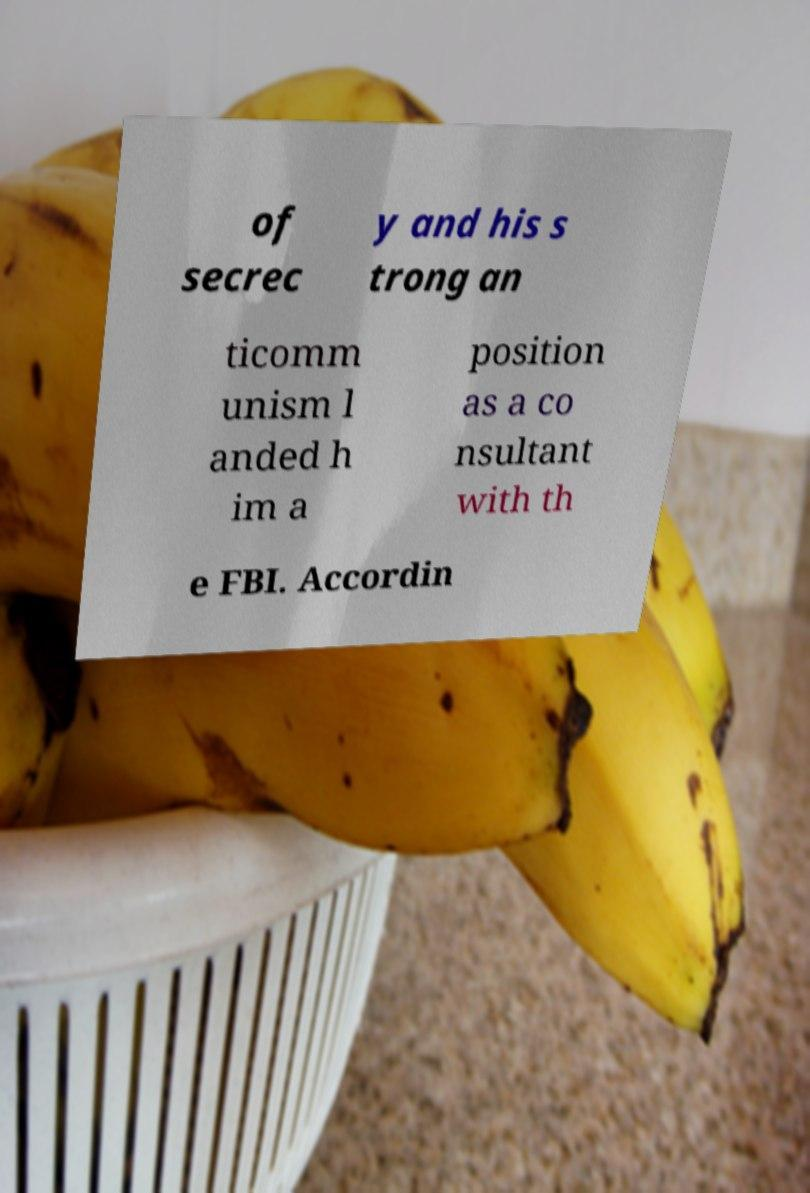Can you accurately transcribe the text from the provided image for me? of secrec y and his s trong an ticomm unism l anded h im a position as a co nsultant with th e FBI. Accordin 